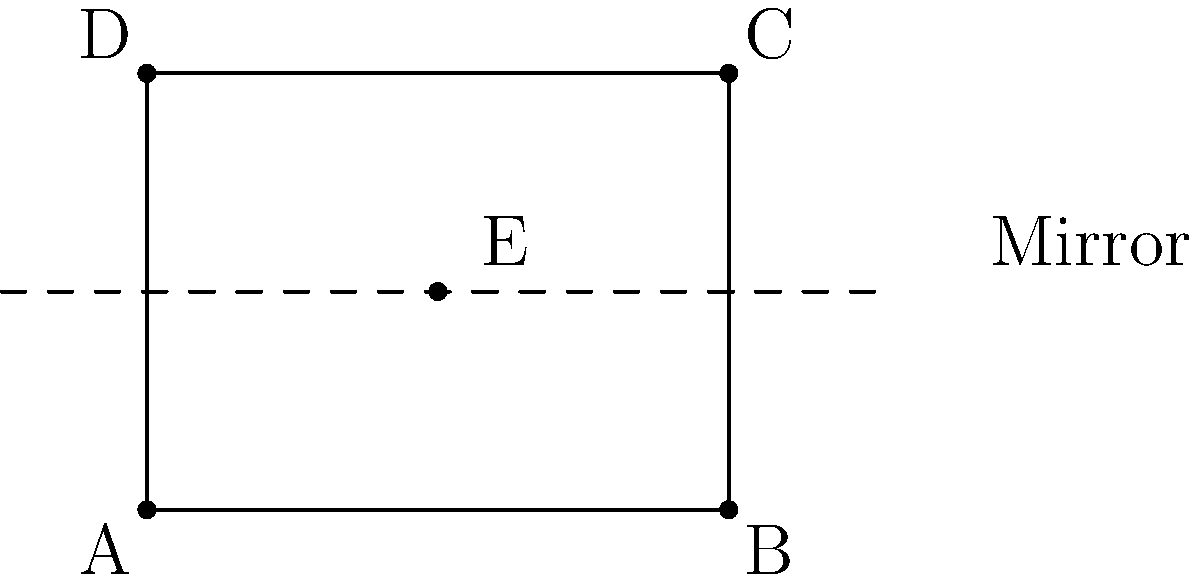For a mirrored dining scene, you need to reflect a symmetrical meal presentation. Given the rectangular table ABCD with dimensions 4 units by 3 units, and a centerpiece at point E(2,1.5), what are the coordinates of the reflected point E' after reflecting across the line y = 1.5? To find the coordinates of the reflected point E', we need to follow these steps:

1. Identify the line of reflection: y = 1.5

2. Understand the principle of reflection: When a point is reflected across a horizontal line, its x-coordinate remains the same, while its y-coordinate changes.

3. Calculate the distance of point E from the line of reflection:
   E is already on the line of reflection (y = 1.5), so the distance is 0.

4. Since E is on the line of reflection, its reflection E' will be at the same point.

5. Therefore, the coordinates of E' will be the same as E:
   E' = (2, 1.5)

This result shows that the meal presentation is already symmetrically placed for the mirrored dining scene, as it lies exactly on the line of reflection.
Answer: (2, 1.5) 